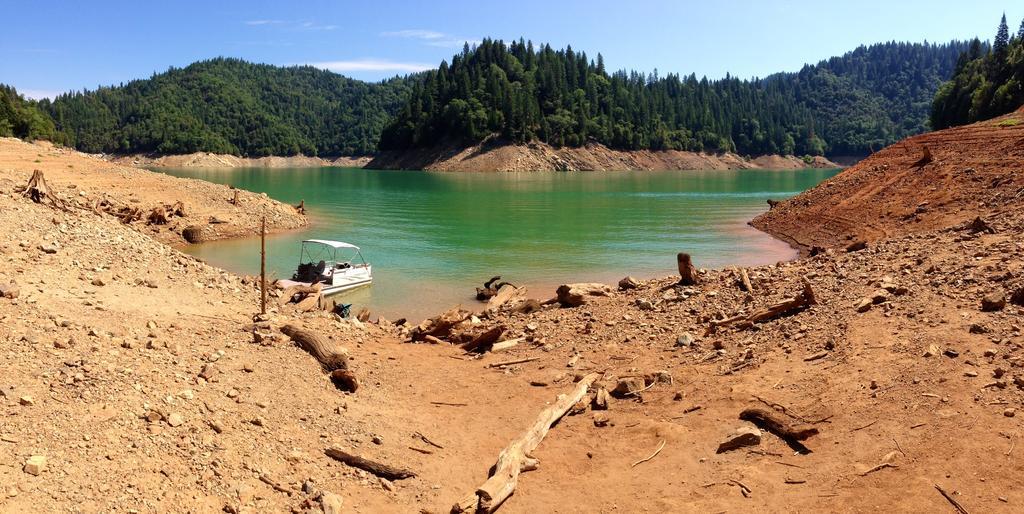Could you give a brief overview of what you see in this image? In this image in front there is mud, wooden sticks, stones. In the center of the image there is a boat in the water. In the background of the image there are trees and sky. 